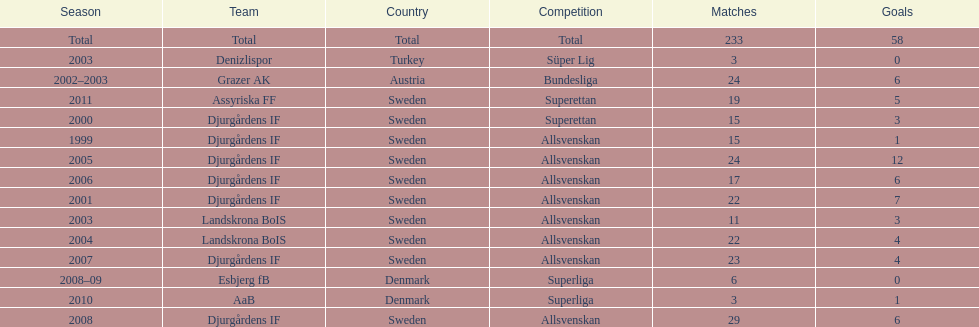What country is team djurgårdens if not from? Sweden. Could you parse the entire table? {'header': ['Season', 'Team', 'Country', 'Competition', 'Matches', 'Goals'], 'rows': [['Total', 'Total', 'Total', 'Total', '233', '58'], ['2003', 'Denizlispor', 'Turkey', 'Süper Lig', '3', '0'], ['2002–2003', 'Grazer AK', 'Austria', 'Bundesliga', '24', '6'], ['2011', 'Assyriska FF', 'Sweden', 'Superettan', '19', '5'], ['2000', 'Djurgårdens IF', 'Sweden', 'Superettan', '15', '3'], ['1999', 'Djurgårdens IF', 'Sweden', 'Allsvenskan', '15', '1'], ['2005', 'Djurgårdens IF', 'Sweden', 'Allsvenskan', '24', '12'], ['2006', 'Djurgårdens IF', 'Sweden', 'Allsvenskan', '17', '6'], ['2001', 'Djurgårdens IF', 'Sweden', 'Allsvenskan', '22', '7'], ['2003', 'Landskrona BoIS', 'Sweden', 'Allsvenskan', '11', '3'], ['2004', 'Landskrona BoIS', 'Sweden', 'Allsvenskan', '22', '4'], ['2007', 'Djurgårdens IF', 'Sweden', 'Allsvenskan', '23', '4'], ['2008–09', 'Esbjerg fB', 'Denmark', 'Superliga', '6', '0'], ['2010', 'AaB', 'Denmark', 'Superliga', '3', '1'], ['2008', 'Djurgårdens IF', 'Sweden', 'Allsvenskan', '29', '6']]} 